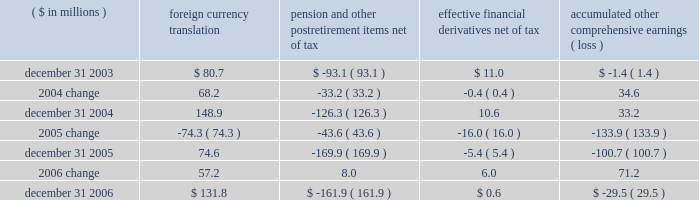Page 73 of 98 notes to consolidated financial statements ball corporation and subsidiaries 15 .
Shareholders 2019 equity at december 31 , 2006 , the company had 550 million shares of common stock and 15 million shares of preferred stock authorized , both without par value .
Preferred stock includes 120000 authorized but unissued shares designated as series a junior participating preferred stock .
Under the company 2019s shareholder rights agreement dated july 26 , 2006 , one preferred stock purchase right ( right ) is attached to each outstanding share of ball corporation common stock .
Subject to adjustment , each right entitles the registered holder to purchase from the company one one-thousandth of a share of series a junior participating preferred stock at an exercise price of $ 185 per right .
If a person or group acquires 10 percent or more of the company 2019s outstanding common stock ( or upon occurrence of certain other events ) , the rights ( other than those held by the acquiring person ) become exercisable and generally entitle the holder to purchase shares of ball corporation common stock at a 50 percent discount .
The rights , which expire in 2016 , are redeemable by the company at a redemption price of $ 0.001 per right and trade with the common stock .
Exercise of such rights would cause substantial dilution to a person or group attempting to acquire control of the company without the approval of ball 2019s board of directors .
The rights would not interfere with any merger or other business combinations approved by the board of directors .
The company reduced its share repurchase program in 2006 to $ 45.7 million , net of issuances , compared to $ 358.1 million net repurchases in 2005 and $ 50 million in 2004 .
The net repurchases in 2006 did not include a forward contract entered into in december 2006 for the repurchase of 1200000 shares .
The contract was settled on january 5 , 2007 , for $ 51.9 million in cash .
In connection with the employee stock purchase plan , the company contributes 20 percent of up to $ 500 of each participating employee 2019s monthly payroll deduction toward the purchase of ball corporation common stock .
Company contributions for this plan were $ 3.2 million in 2006 , $ 3.2 million in 2005 and $ 2.7 million in 2004 .
Accumulated other comprehensive earnings ( loss ) the activity related to accumulated other comprehensive earnings ( loss ) was as follows : ( $ in millions ) foreign currency translation pension and postretirement items , net of tax effective financial derivatives , net of tax accumulated comprehensive earnings ( loss ) .
Notwithstanding the 2005 distribution pursuant to the jobs act , management 2019s intention is to indefinitely reinvest foreign earnings .
Therefore , no taxes have been provided on the foreign currency translation component for any period .
The change in the minimum pension liability is presented net of related tax expense of $ 2.9 million for 2006 and related tax benefits of $ 27.3 million and $ 20.8 million for 2005 and 2004 , respectively .
The change in the effective financial derivatives is presented net of related tax expense of $ 5.7 million for 2006 , related tax benefit of $ 10.7 million for 2005 and related tax benefit of $ 0.2 million for 2004. .
What was the percentage reduction in the share repurchase program , from 2005 to 2006? 
Computations: ((358.1 - 45.7) / 358.1)
Answer: 0.87238. Page 73 of 98 notes to consolidated financial statements ball corporation and subsidiaries 15 .
Shareholders 2019 equity at december 31 , 2006 , the company had 550 million shares of common stock and 15 million shares of preferred stock authorized , both without par value .
Preferred stock includes 120000 authorized but unissued shares designated as series a junior participating preferred stock .
Under the company 2019s shareholder rights agreement dated july 26 , 2006 , one preferred stock purchase right ( right ) is attached to each outstanding share of ball corporation common stock .
Subject to adjustment , each right entitles the registered holder to purchase from the company one one-thousandth of a share of series a junior participating preferred stock at an exercise price of $ 185 per right .
If a person or group acquires 10 percent or more of the company 2019s outstanding common stock ( or upon occurrence of certain other events ) , the rights ( other than those held by the acquiring person ) become exercisable and generally entitle the holder to purchase shares of ball corporation common stock at a 50 percent discount .
The rights , which expire in 2016 , are redeemable by the company at a redemption price of $ 0.001 per right and trade with the common stock .
Exercise of such rights would cause substantial dilution to a person or group attempting to acquire control of the company without the approval of ball 2019s board of directors .
The rights would not interfere with any merger or other business combinations approved by the board of directors .
The company reduced its share repurchase program in 2006 to $ 45.7 million , net of issuances , compared to $ 358.1 million net repurchases in 2005 and $ 50 million in 2004 .
The net repurchases in 2006 did not include a forward contract entered into in december 2006 for the repurchase of 1200000 shares .
The contract was settled on january 5 , 2007 , for $ 51.9 million in cash .
In connection with the employee stock purchase plan , the company contributes 20 percent of up to $ 500 of each participating employee 2019s monthly payroll deduction toward the purchase of ball corporation common stock .
Company contributions for this plan were $ 3.2 million in 2006 , $ 3.2 million in 2005 and $ 2.7 million in 2004 .
Accumulated other comprehensive earnings ( loss ) the activity related to accumulated other comprehensive earnings ( loss ) was as follows : ( $ in millions ) foreign currency translation pension and postretirement items , net of tax effective financial derivatives , net of tax accumulated comprehensive earnings ( loss ) .
Notwithstanding the 2005 distribution pursuant to the jobs act , management 2019s intention is to indefinitely reinvest foreign earnings .
Therefore , no taxes have been provided on the foreign currency translation component for any period .
The change in the minimum pension liability is presented net of related tax expense of $ 2.9 million for 2006 and related tax benefits of $ 27.3 million and $ 20.8 million for 2005 and 2004 , respectively .
The change in the effective financial derivatives is presented net of related tax expense of $ 5.7 million for 2006 , related tax benefit of $ 10.7 million for 2005 and related tax benefit of $ 0.2 million for 2004. .
What was the percentage change in accumulated other comprehensive earnings ( loss ) between 2004 and 2005?\\n? 
Computations: (-133.9 / 33.2)
Answer: -4.03313. 